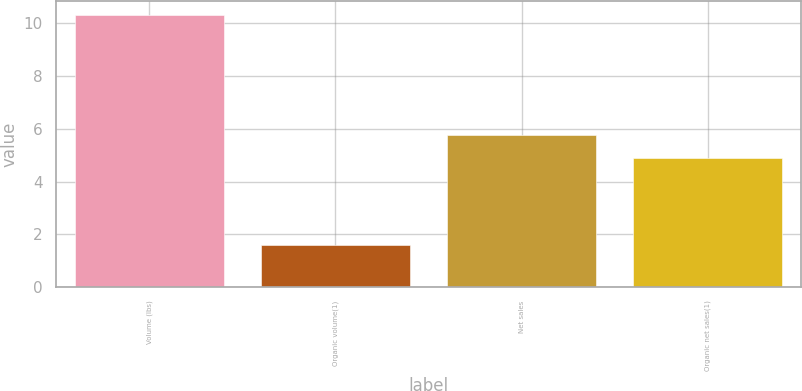Convert chart to OTSL. <chart><loc_0><loc_0><loc_500><loc_500><bar_chart><fcel>Volume (lbs)<fcel>Organic volume(1)<fcel>Net sales<fcel>Organic net sales(1)<nl><fcel>10.3<fcel>1.6<fcel>5.77<fcel>4.9<nl></chart> 